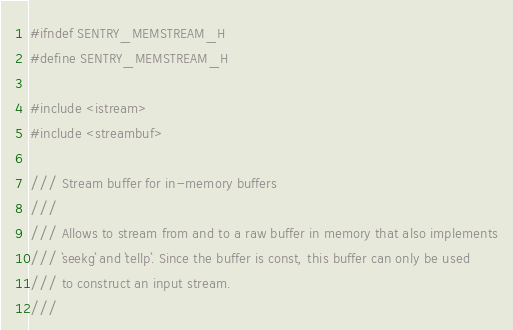<code> <loc_0><loc_0><loc_500><loc_500><_C_>#ifndef SENTRY_MEMSTREAM_H
#define SENTRY_MEMSTREAM_H

#include <istream>
#include <streambuf>

/// Stream buffer for in-memory buffers
///
/// Allows to stream from and to a raw buffer in memory that also implements
/// `seekg` and `tellp`. Since the buffer is const, this buffer can only be used
/// to construct an input stream.
///</code> 